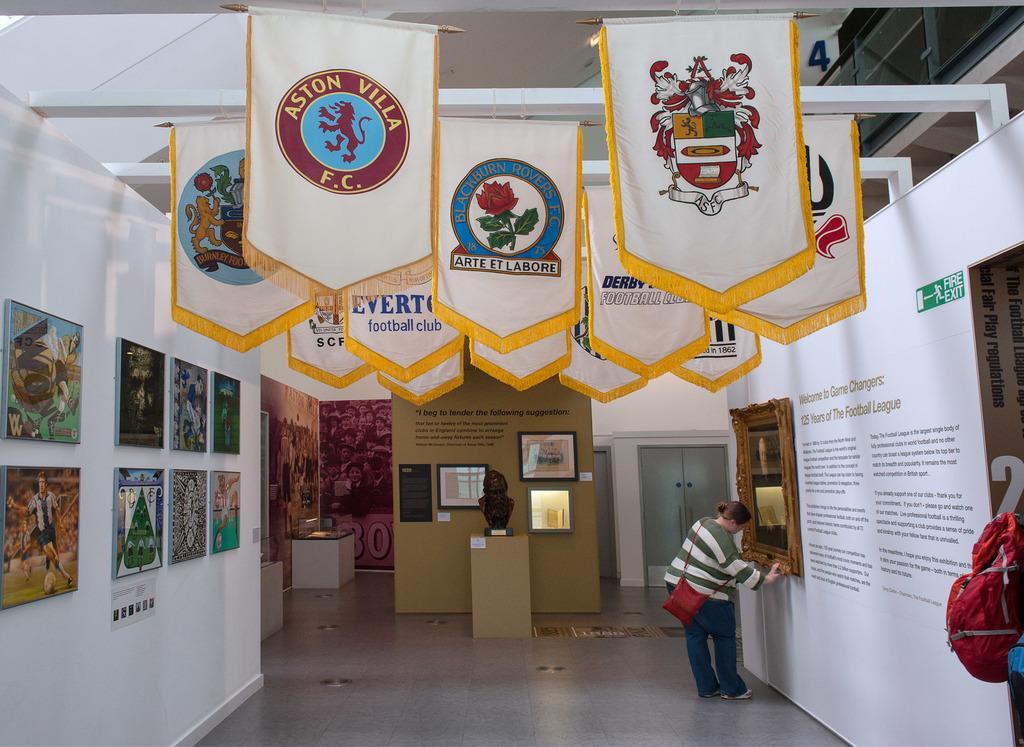Please provide a concise description of this image. On the left side there is a wall with many paintings. On the ceiling there are rods with flags. On the right side there is a wall with a frame and something written on that. Near to that there is a lady wearing a bag is standing. In the back there is a statue on a stand. Also there is a wall with frames. And there is a door in the background. And also there is a red bag on the right side. 